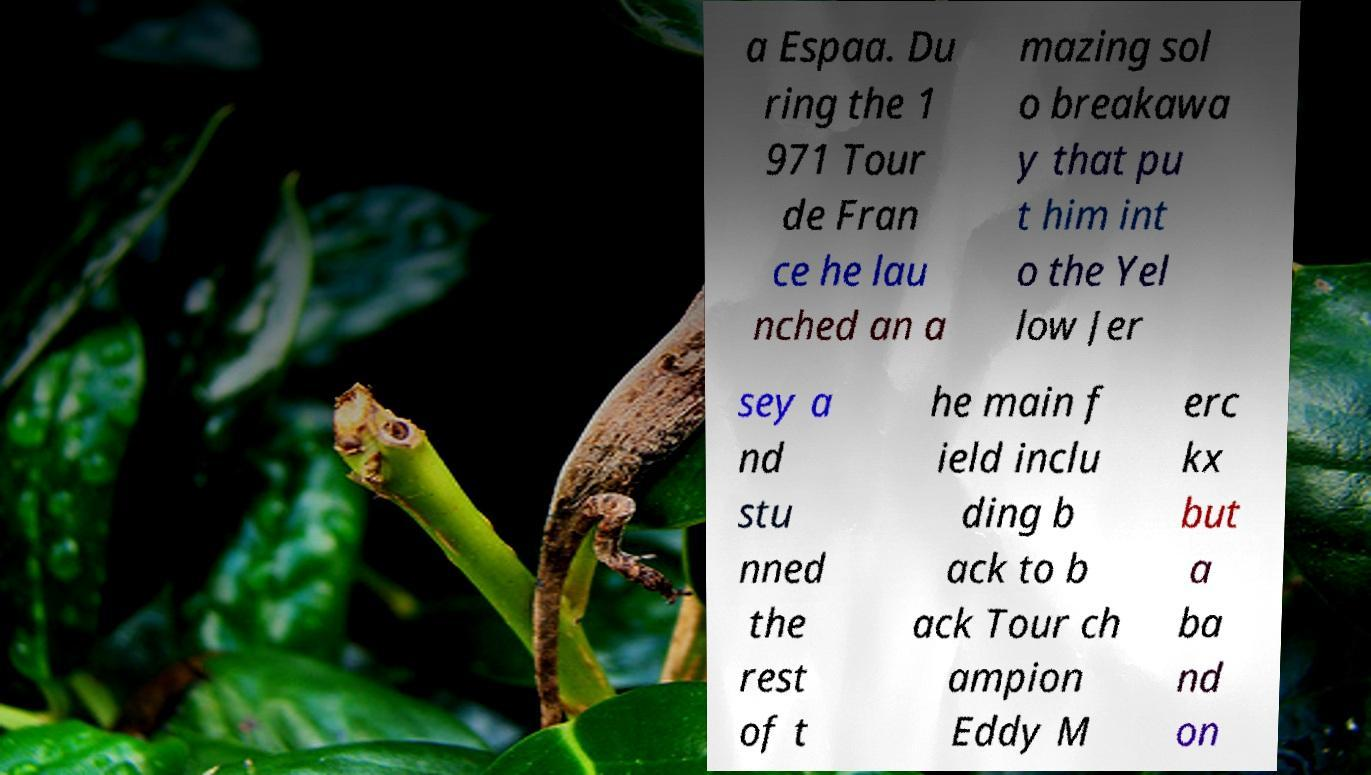I need the written content from this picture converted into text. Can you do that? a Espaa. Du ring the 1 971 Tour de Fran ce he lau nched an a mazing sol o breakawa y that pu t him int o the Yel low Jer sey a nd stu nned the rest of t he main f ield inclu ding b ack to b ack Tour ch ampion Eddy M erc kx but a ba nd on 